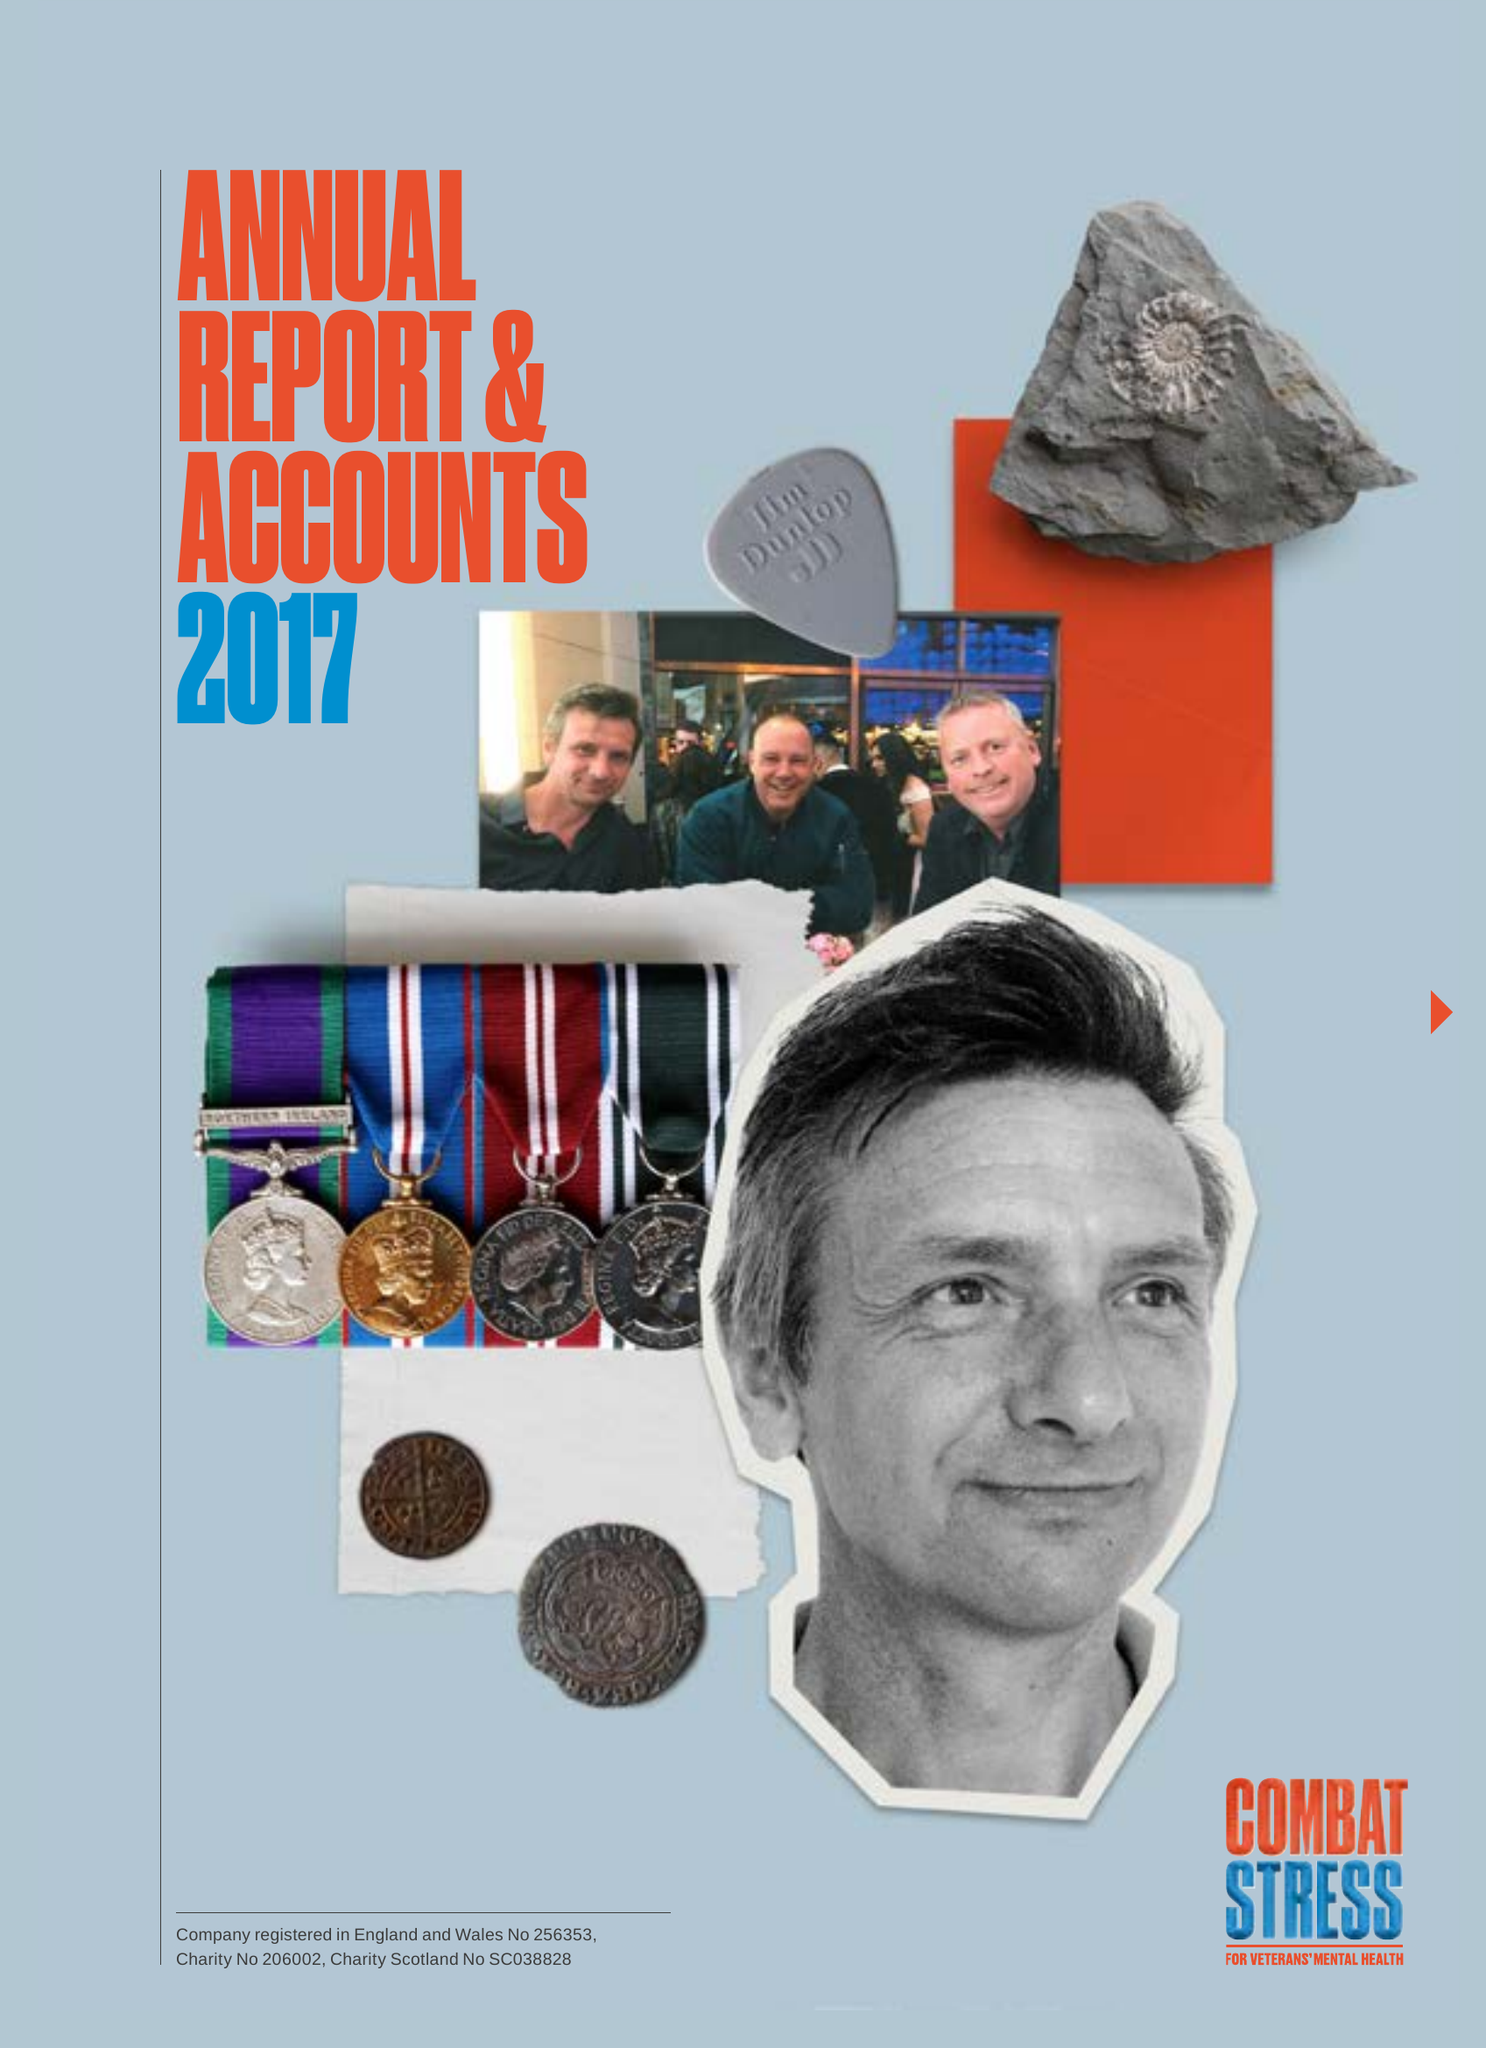What is the value for the address__postcode?
Answer the question using a single word or phrase. KT22 0BX 